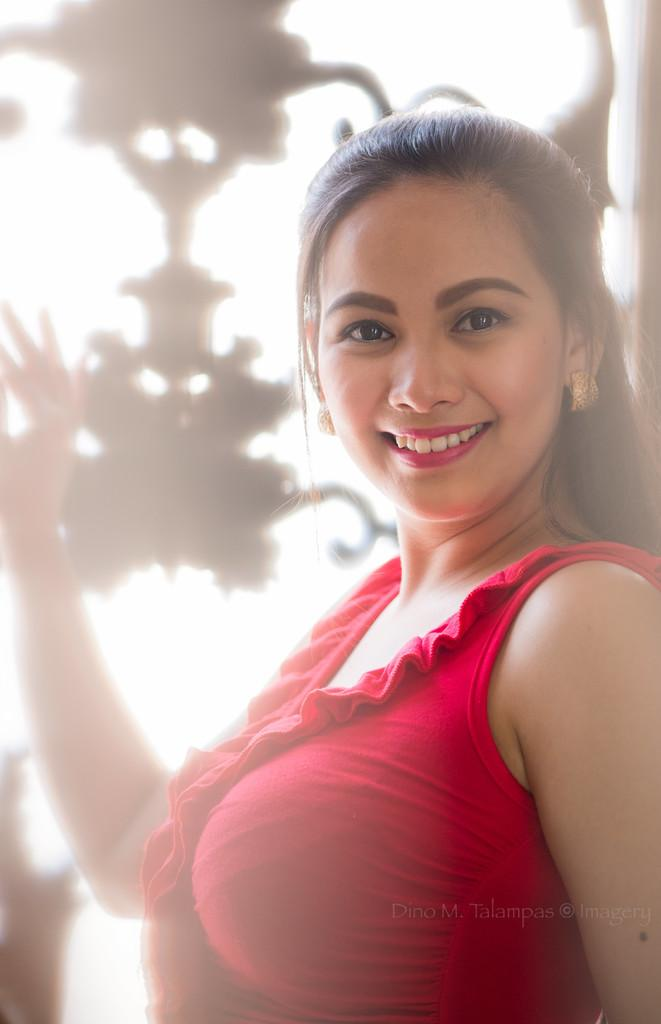Who or what is the main subject of the image? There is a person in the image. What is the person doing in the image? The person is smiling. What can be seen behind the person in the image? There are objects behind the person. What is written or displayed at the bottom of the image? There is text at the bottom of the image. What type of stem can be seen growing from the person's head in the image? There is no stem growing from the person's head in the image. What belief system does the person in the image follow? The image does not provide any information about the person's beliefs or belief system. 